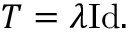<formula> <loc_0><loc_0><loc_500><loc_500>T = \lambda { I d } .</formula> 